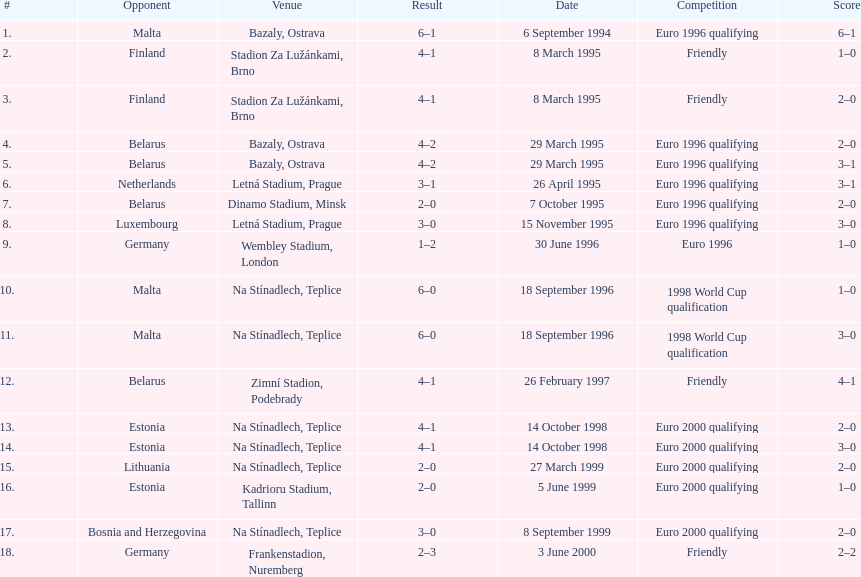How many times have the czech republic and germany faced each other in matches? 2. 